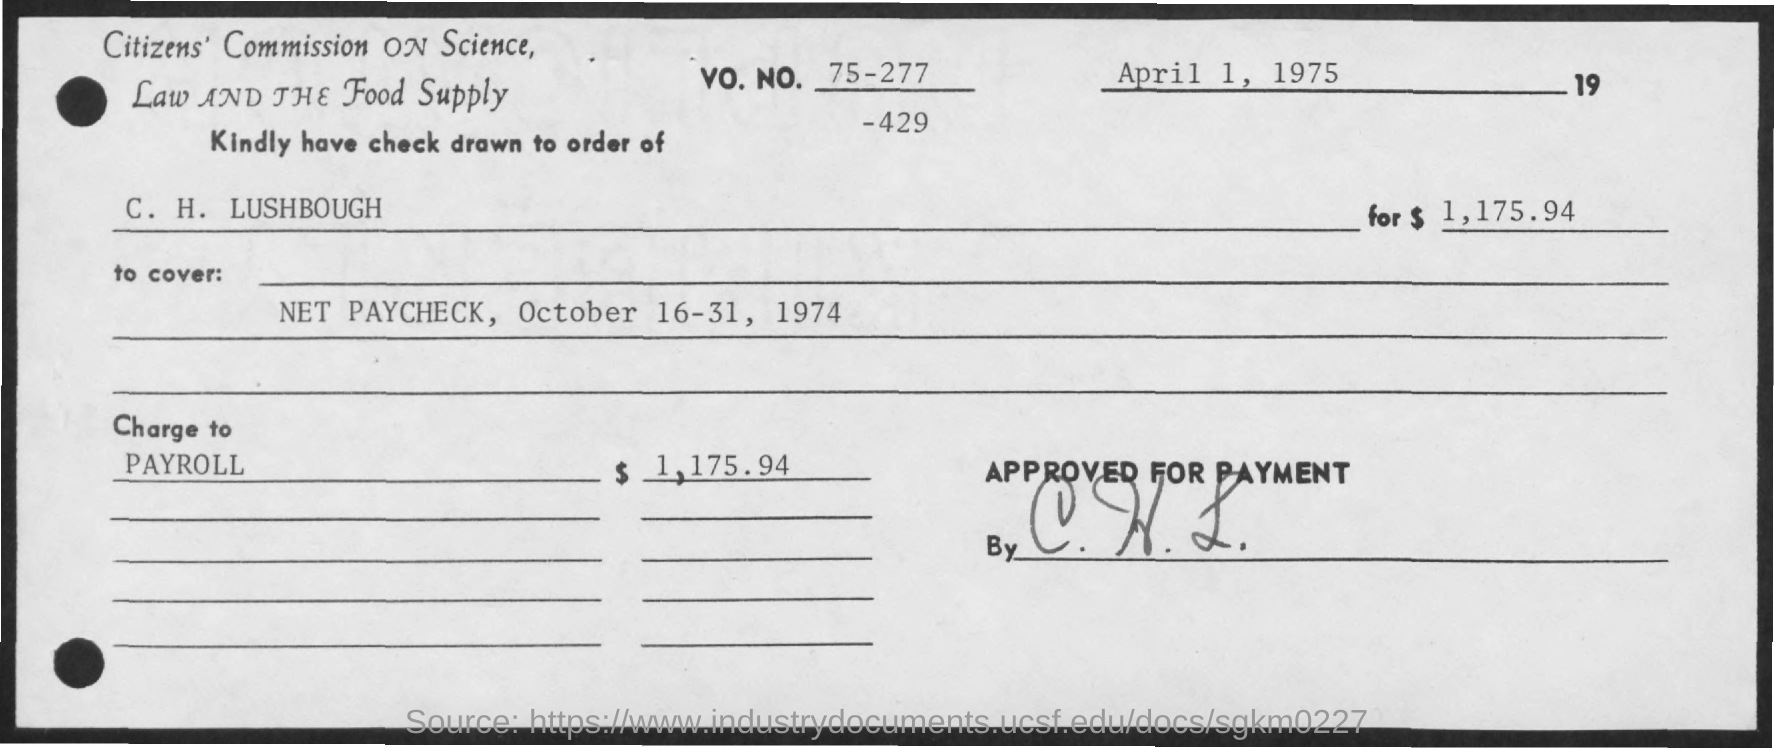Identify some key points in this picture. The check for the period of October 16-31, 1974, was drawn to cover the net paycheck. The VO. NO. is 75-277-429. What is the purpose of charge to payroll? The check is drawn to the order of C. H. Lushbough. 